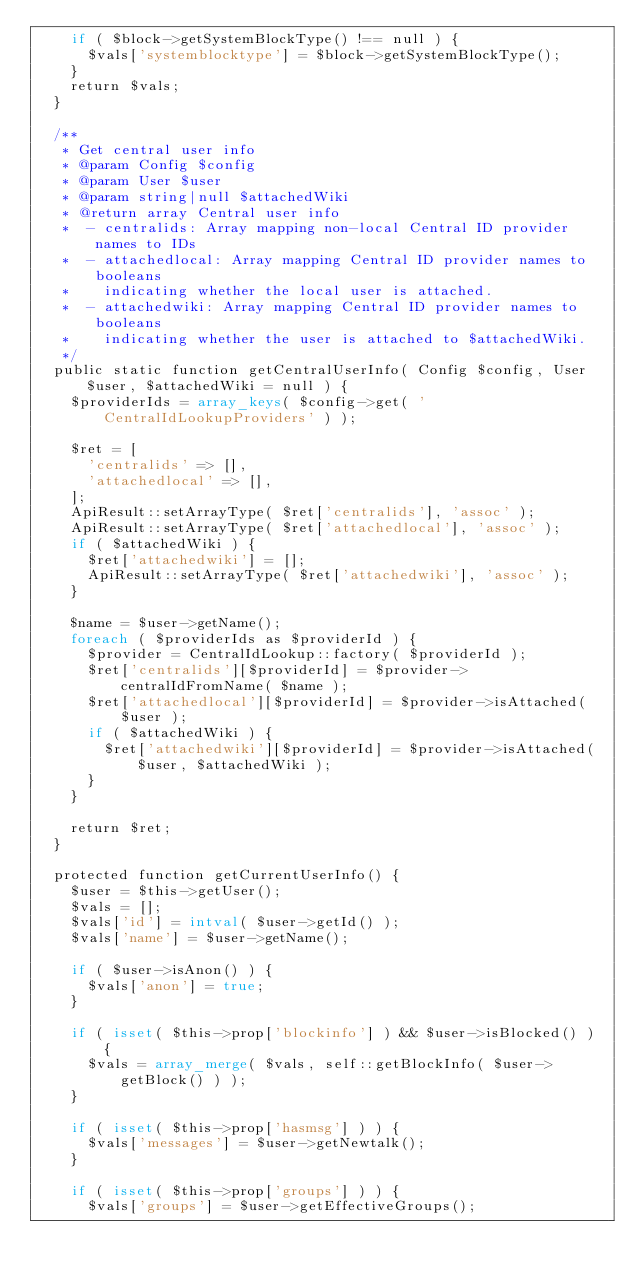<code> <loc_0><loc_0><loc_500><loc_500><_PHP_>		if ( $block->getSystemBlockType() !== null ) {
			$vals['systemblocktype'] = $block->getSystemBlockType();
		}
		return $vals;
	}

	/**
	 * Get central user info
	 * @param Config $config
	 * @param User $user
	 * @param string|null $attachedWiki
	 * @return array Central user info
	 *  - centralids: Array mapping non-local Central ID provider names to IDs
	 *  - attachedlocal: Array mapping Central ID provider names to booleans
	 *    indicating whether the local user is attached.
	 *  - attachedwiki: Array mapping Central ID provider names to booleans
	 *    indicating whether the user is attached to $attachedWiki.
	 */
	public static function getCentralUserInfo( Config $config, User $user, $attachedWiki = null ) {
		$providerIds = array_keys( $config->get( 'CentralIdLookupProviders' ) );

		$ret = [
			'centralids' => [],
			'attachedlocal' => [],
		];
		ApiResult::setArrayType( $ret['centralids'], 'assoc' );
		ApiResult::setArrayType( $ret['attachedlocal'], 'assoc' );
		if ( $attachedWiki ) {
			$ret['attachedwiki'] = [];
			ApiResult::setArrayType( $ret['attachedwiki'], 'assoc' );
		}

		$name = $user->getName();
		foreach ( $providerIds as $providerId ) {
			$provider = CentralIdLookup::factory( $providerId );
			$ret['centralids'][$providerId] = $provider->centralIdFromName( $name );
			$ret['attachedlocal'][$providerId] = $provider->isAttached( $user );
			if ( $attachedWiki ) {
				$ret['attachedwiki'][$providerId] = $provider->isAttached( $user, $attachedWiki );
			}
		}

		return $ret;
	}

	protected function getCurrentUserInfo() {
		$user = $this->getUser();
		$vals = [];
		$vals['id'] = intval( $user->getId() );
		$vals['name'] = $user->getName();

		if ( $user->isAnon() ) {
			$vals['anon'] = true;
		}

		if ( isset( $this->prop['blockinfo'] ) && $user->isBlocked() ) {
			$vals = array_merge( $vals, self::getBlockInfo( $user->getBlock() ) );
		}

		if ( isset( $this->prop['hasmsg'] ) ) {
			$vals['messages'] = $user->getNewtalk();
		}

		if ( isset( $this->prop['groups'] ) ) {
			$vals['groups'] = $user->getEffectiveGroups();</code> 